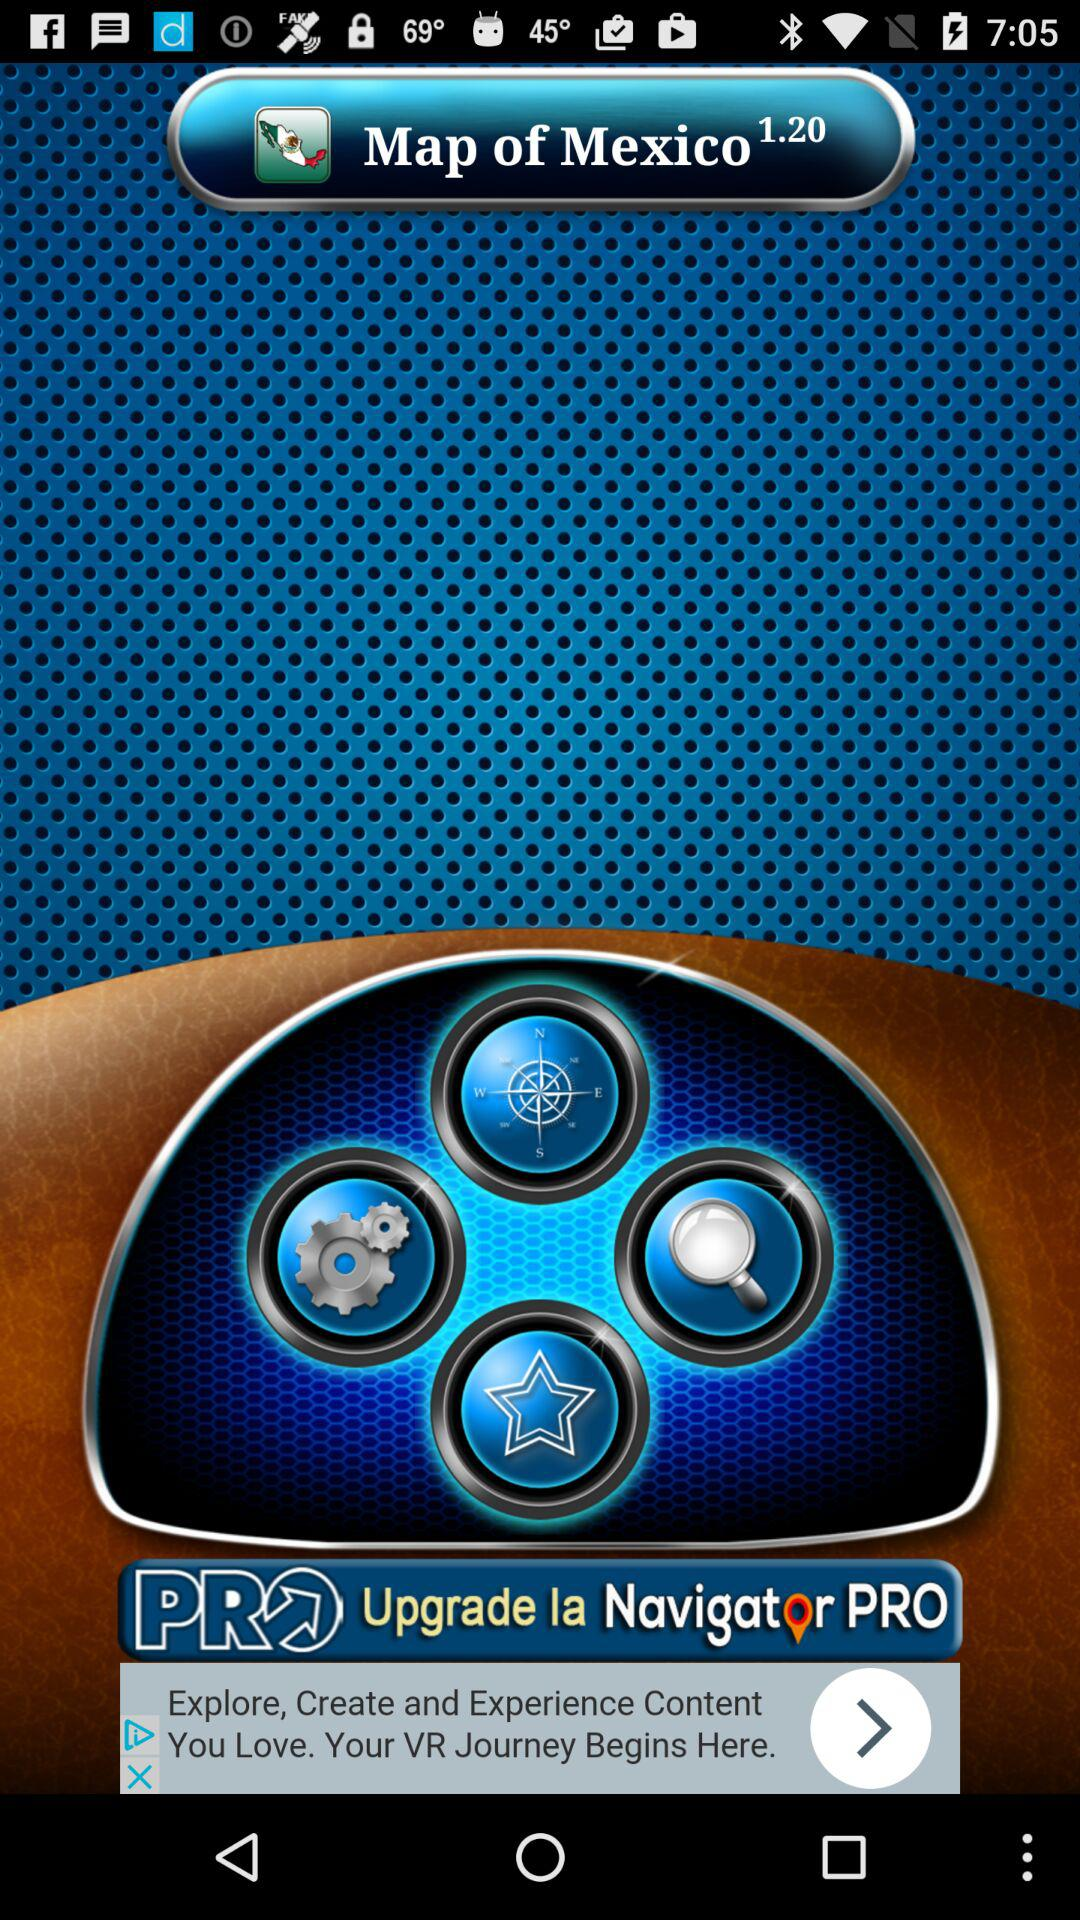What is the name of the application? The name of the application is "Map of Mexico". 